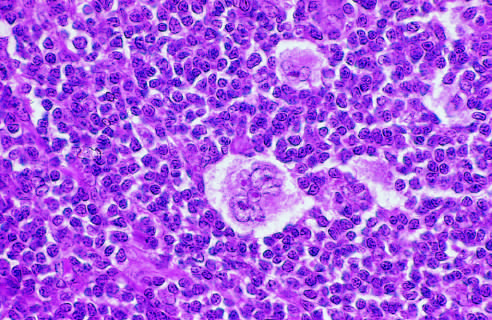what is seen lying within a clear space created by retraction of its cytoplasms?
Answer the question using a single word or phrase. A distinctive lacunar cell with a multilobed nucleus containing many small nucleoli 